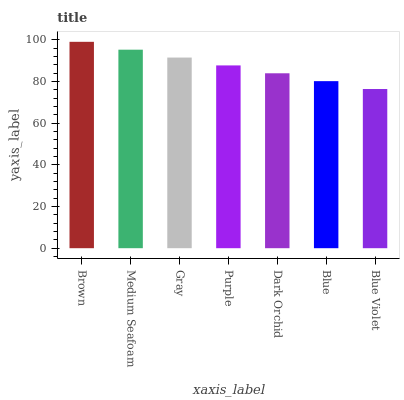Is Blue Violet the minimum?
Answer yes or no. Yes. Is Brown the maximum?
Answer yes or no. Yes. Is Medium Seafoam the minimum?
Answer yes or no. No. Is Medium Seafoam the maximum?
Answer yes or no. No. Is Brown greater than Medium Seafoam?
Answer yes or no. Yes. Is Medium Seafoam less than Brown?
Answer yes or no. Yes. Is Medium Seafoam greater than Brown?
Answer yes or no. No. Is Brown less than Medium Seafoam?
Answer yes or no. No. Is Purple the high median?
Answer yes or no. Yes. Is Purple the low median?
Answer yes or no. Yes. Is Blue the high median?
Answer yes or no. No. Is Blue the low median?
Answer yes or no. No. 